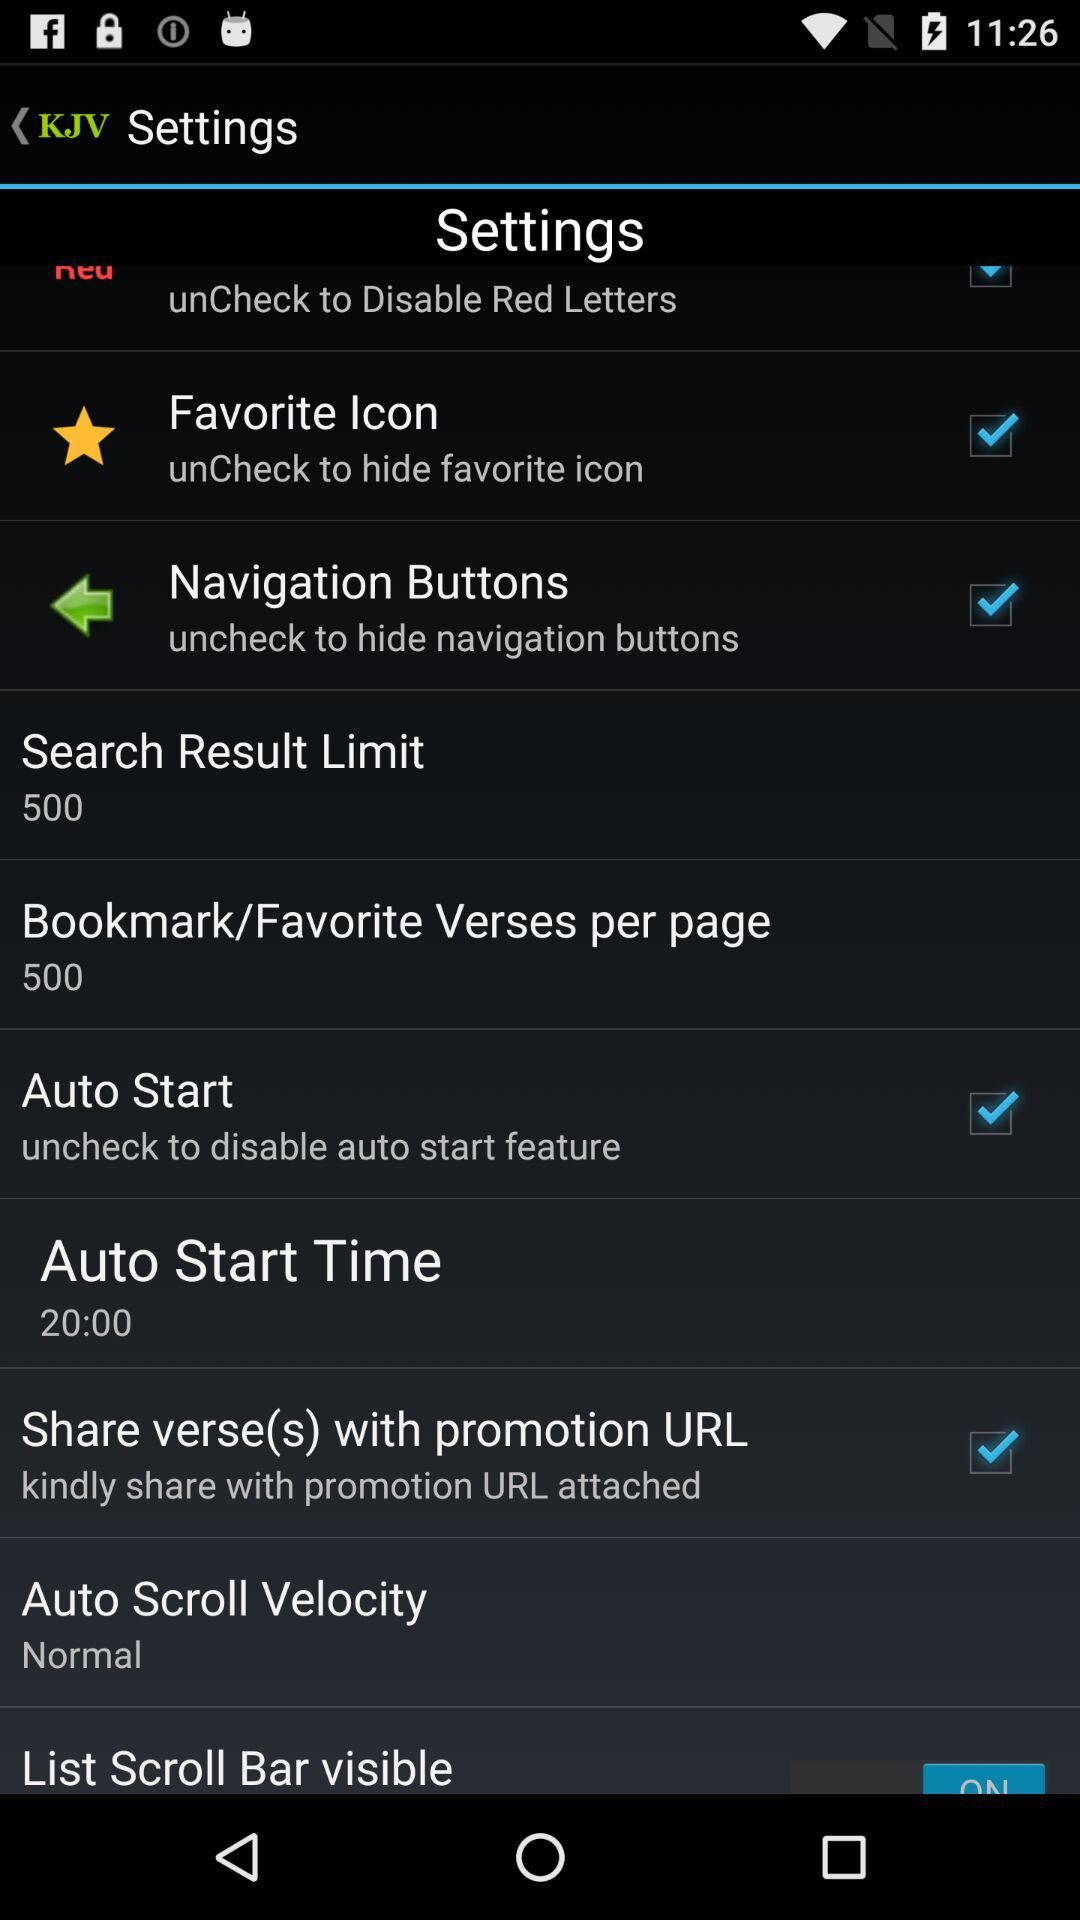What is the current status of the "Auto Start"? The current status is "on". 